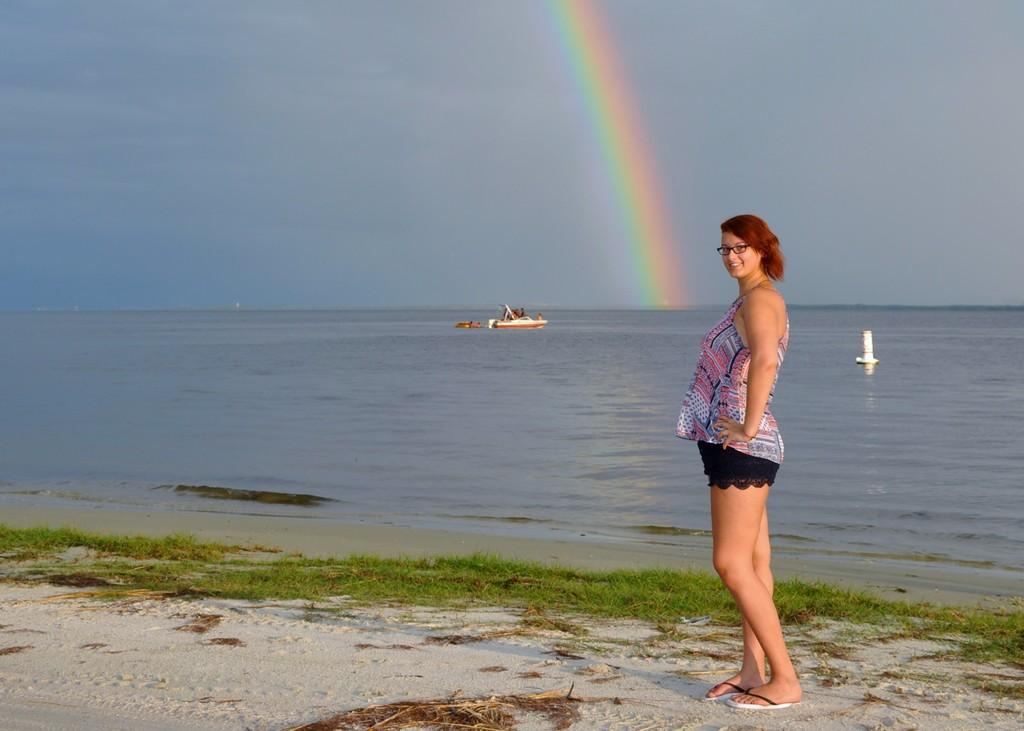What is the person in the image standing on? The person is standing on land with grass in the image. What can be seen on the person's face? The person is wearing spectacles. What is happening on the water in the image? There is a boat sailing on water in the image. What is visible at the top of the image? The sky is visible at the top of the image. What additional feature can be seen in the sky? There is a rainbow in the sky. How many friends are sitting on the wing of the boat in the image? There is no wing on the boat in the image, and no friends are present. 